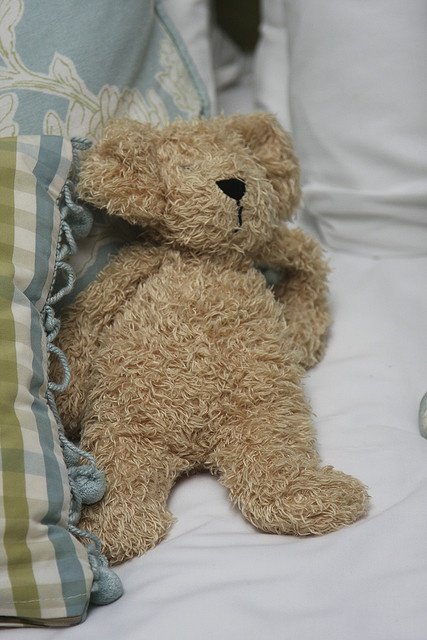Describe the objects in this image and their specific colors. I can see teddy bear in darkgray, tan, and gray tones and bed in darkgray and lightgray tones in this image. 